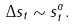Convert formula to latex. <formula><loc_0><loc_0><loc_500><loc_500>\Delta s _ { t } \sim s _ { t } ^ { \alpha } .</formula> 